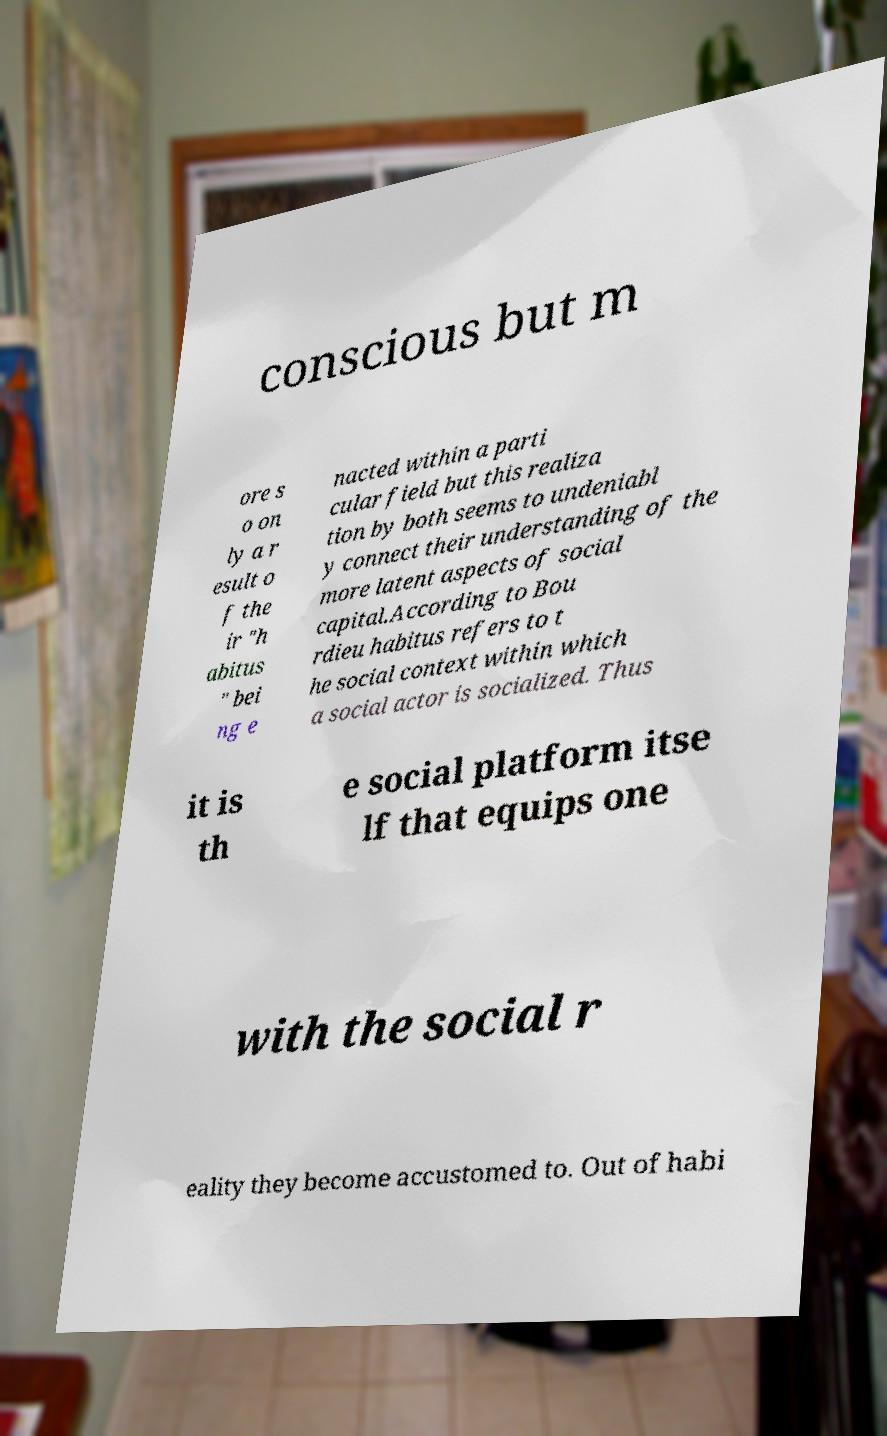What messages or text are displayed in this image? I need them in a readable, typed format. conscious but m ore s o on ly a r esult o f the ir "h abitus " bei ng e nacted within a parti cular field but this realiza tion by both seems to undeniabl y connect their understanding of the more latent aspects of social capital.According to Bou rdieu habitus refers to t he social context within which a social actor is socialized. Thus it is th e social platform itse lf that equips one with the social r eality they become accustomed to. Out of habi 